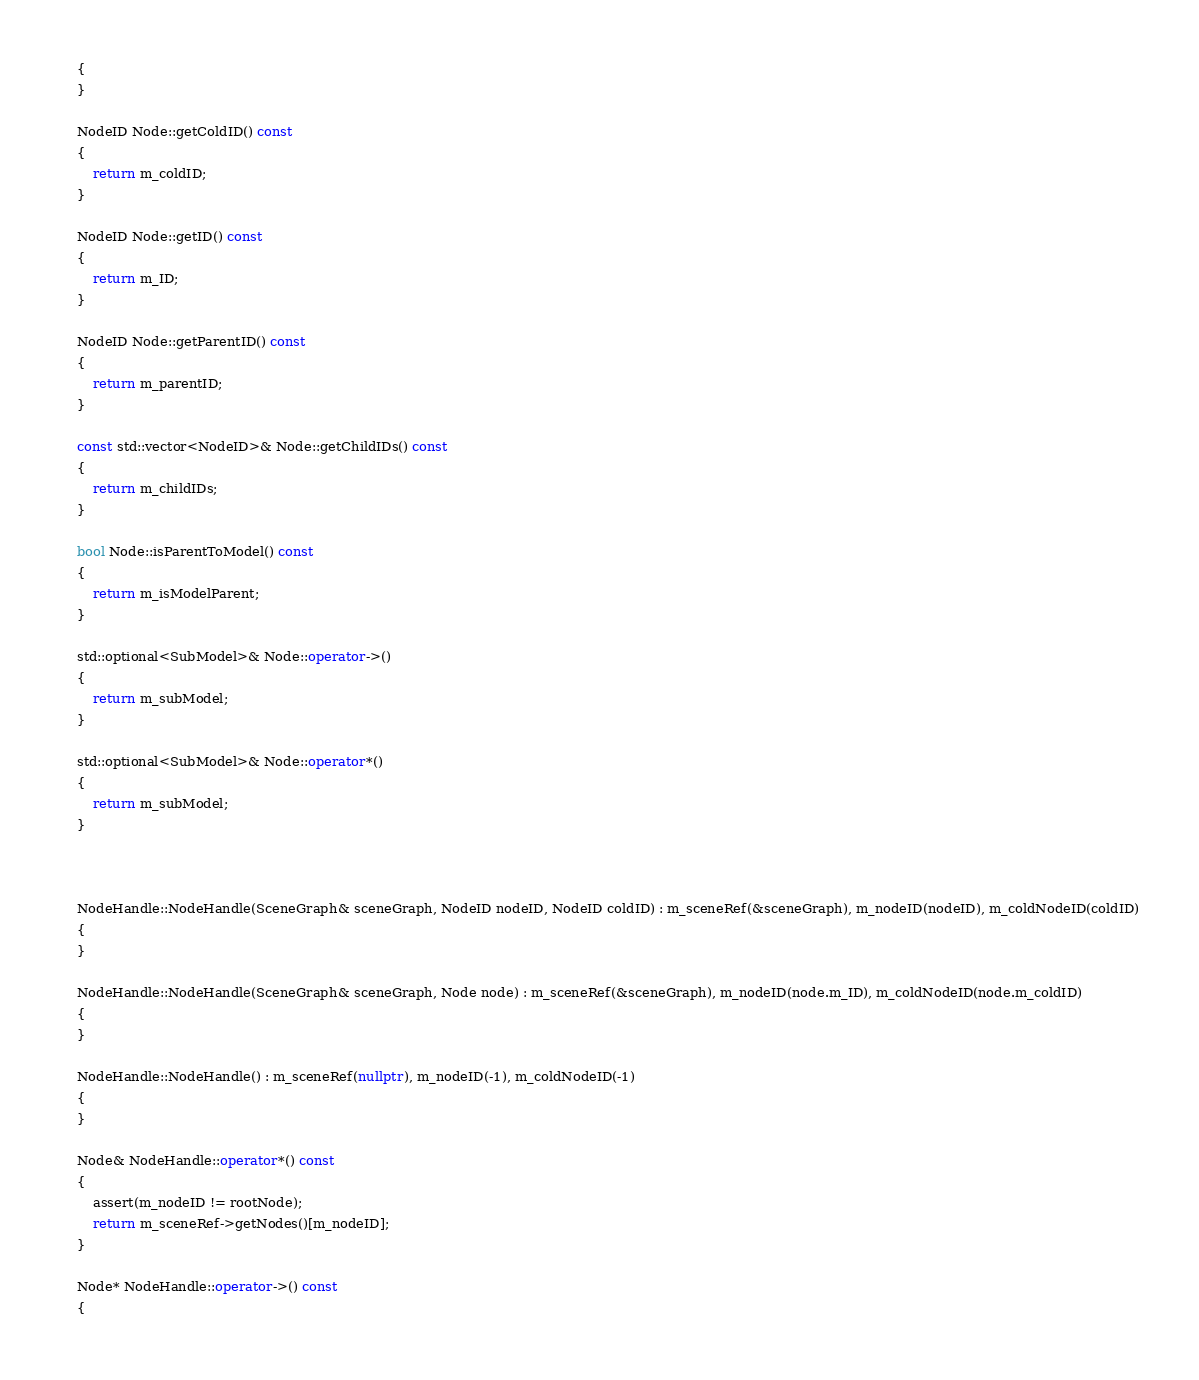Convert code to text. <code><loc_0><loc_0><loc_500><loc_500><_C++_>    {
    }

    NodeID Node::getColdID() const
    {
        return m_coldID;
    }

    NodeID Node::getID() const
    {
        return m_ID;
    }

    NodeID Node::getParentID() const
    {
        return m_parentID;
    }

    const std::vector<NodeID>& Node::getChildIDs() const
    {
        return m_childIDs;
    }

    bool Node::isParentToModel() const
    {
        return m_isModelParent;
    }

    std::optional<SubModel>& Node::operator->()
    {
        return m_subModel;
    }

    std::optional<SubModel>& Node::operator*()
    {
        return m_subModel;
    }



    NodeHandle::NodeHandle(SceneGraph& sceneGraph, NodeID nodeID, NodeID coldID) : m_sceneRef(&sceneGraph), m_nodeID(nodeID), m_coldNodeID(coldID)
    {
    }

    NodeHandle::NodeHandle(SceneGraph& sceneGraph, Node node) : m_sceneRef(&sceneGraph), m_nodeID(node.m_ID), m_coldNodeID(node.m_coldID)
    {
    }

    NodeHandle::NodeHandle() : m_sceneRef(nullptr), m_nodeID(-1), m_coldNodeID(-1)
    {
    }

    Node& NodeHandle::operator*() const
    {
        assert(m_nodeID != rootNode);
        return m_sceneRef->getNodes()[m_nodeID];
    }

    Node* NodeHandle::operator->() const
    {</code> 